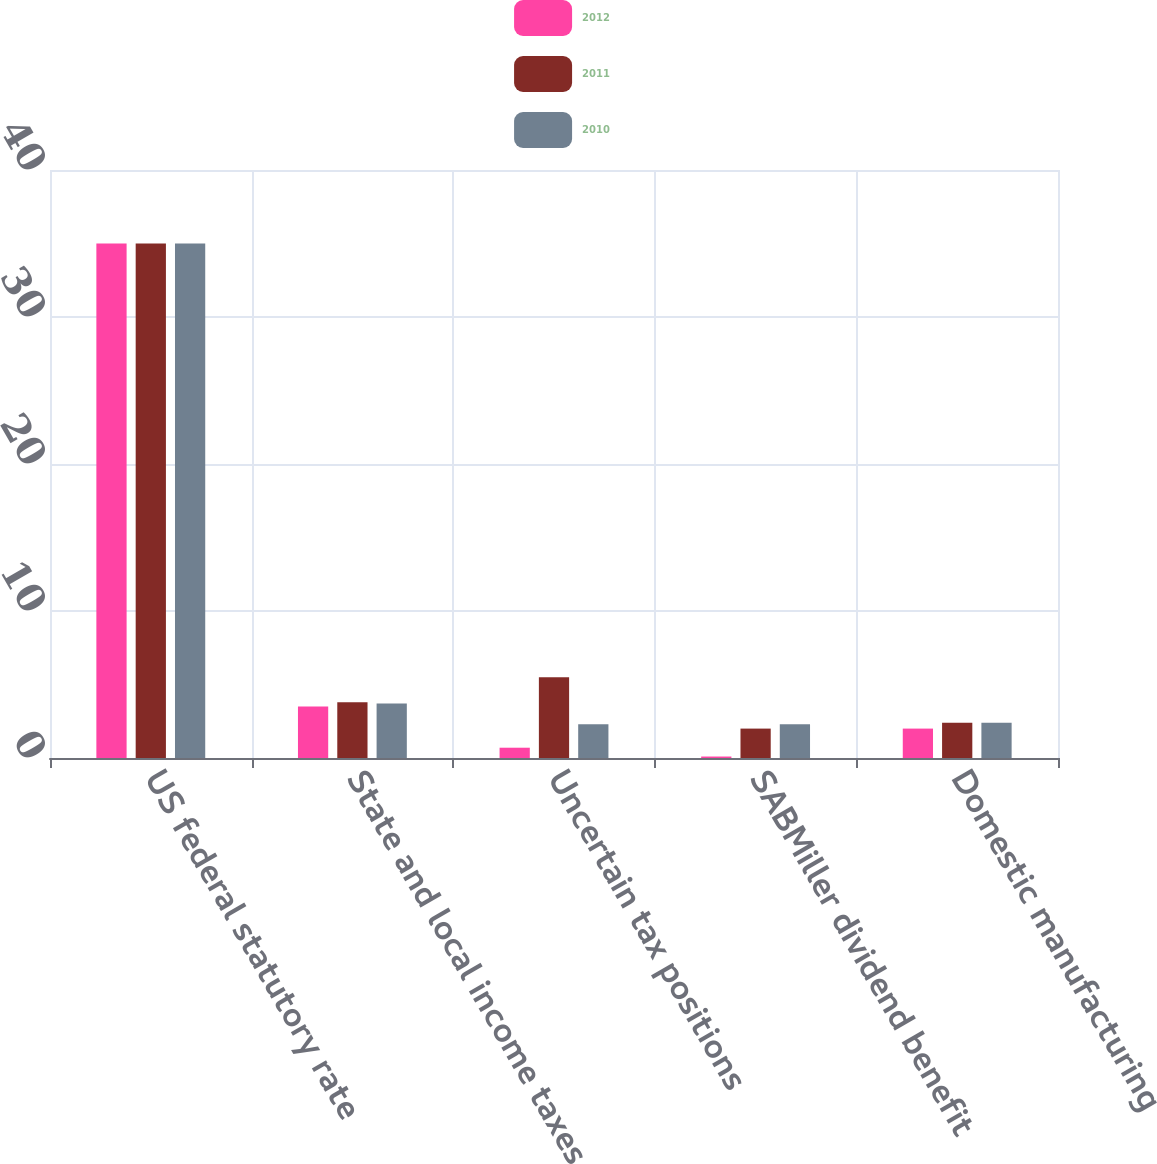Convert chart to OTSL. <chart><loc_0><loc_0><loc_500><loc_500><stacked_bar_chart><ecel><fcel>US federal statutory rate<fcel>State and local income taxes<fcel>Uncertain tax positions<fcel>SABMiller dividend benefit<fcel>Domestic manufacturing<nl><fcel>2012<fcel>35<fcel>3.5<fcel>0.7<fcel>0.1<fcel>2<nl><fcel>2011<fcel>35<fcel>3.8<fcel>5.5<fcel>2<fcel>2.4<nl><fcel>2010<fcel>35<fcel>3.7<fcel>2.3<fcel>2.3<fcel>2.4<nl></chart> 